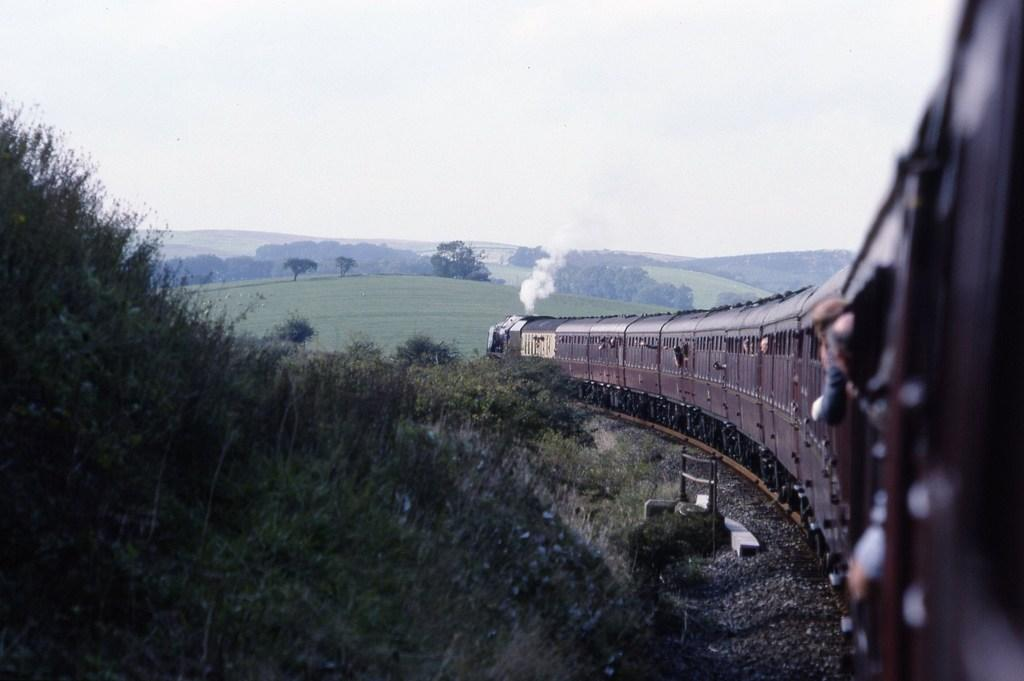What is the main subject of the image? There is a train in the image. Where is the train located in relation to the image? The train is on the right side of the image. What is the train positioned on? The train is on a track. What can be seen on the left side of the image? There is a hill in the image, and it has grass on it. What is visible in the background of the image? The sky is visible in the image. What type of quill can be seen in the image? There is no quill present in the image. What facial expression does the hill have in the image? The hill does not have a face or any facial expression, as it is a natural formation and not an animate object. 